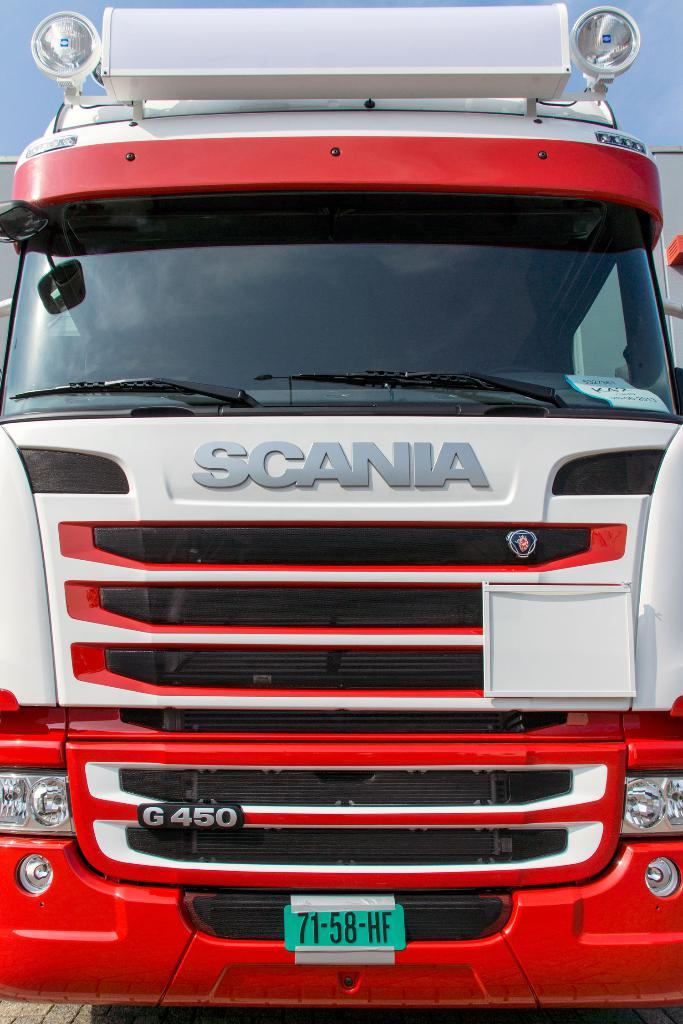What is the main subject in the foreground of the image? There is a vehicle in the foreground of the image. What feature can be seen at the top of the vehicle? There are lamps at the top of the vehicle. Can you identify any other vehicles in the image? It appears that there is another vehicle in the image. What can be seen in the background of the image? The sky is visible in the background of the image. How does the vehicle join the nation in the image? The vehicle does not join the nation in the image; it is simply a vehicle in a scene. Can you describe the walk of the vehicle in the image? The vehicle does not walk in the image; it is stationary. 